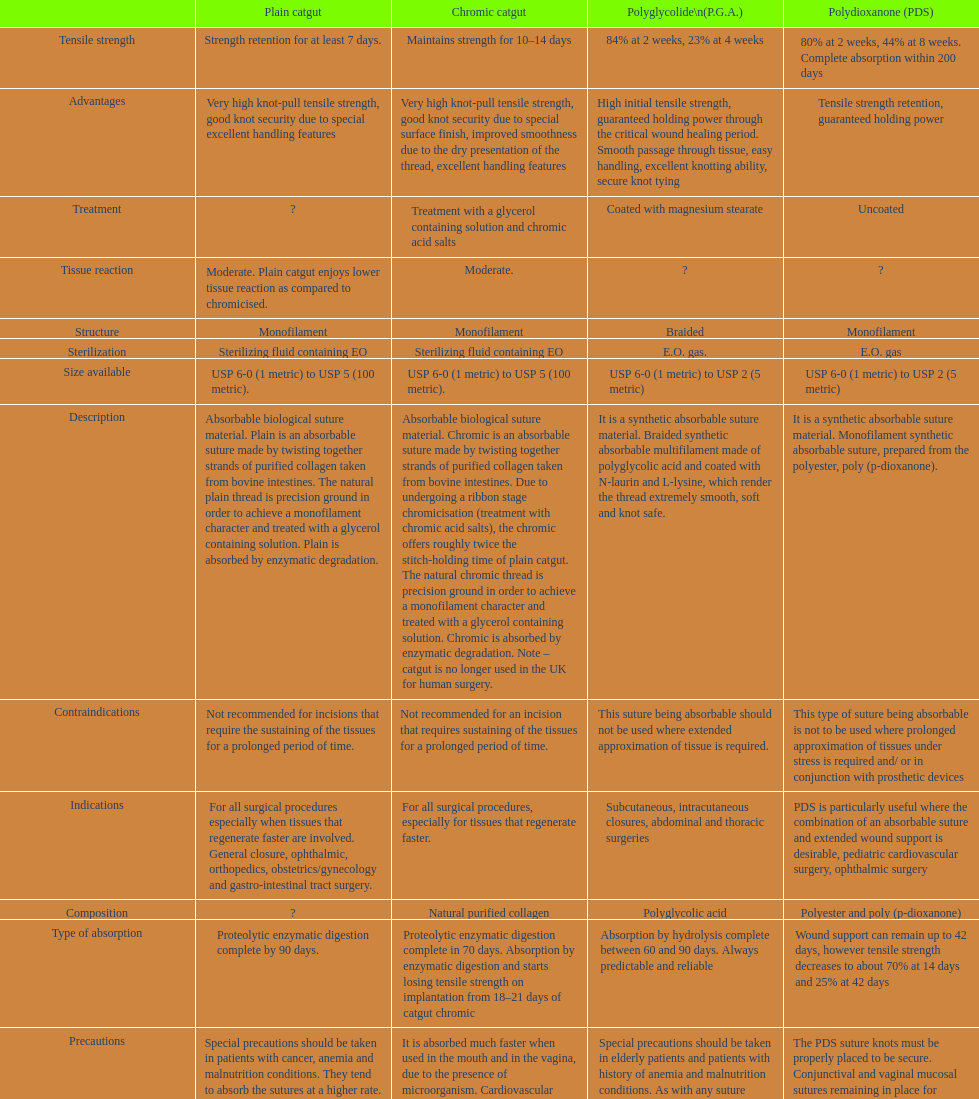Would you mind parsing the complete table? {'header': ['', 'Plain catgut', 'Chromic catgut', 'Polyglycolide\\n(P.G.A.)', 'Polydioxanone (PDS)'], 'rows': [['Tensile strength', 'Strength retention for at least 7 days.', 'Maintains strength for 10–14 days', '84% at 2 weeks, 23% at 4 weeks', '80% at 2 weeks, 44% at 8 weeks. Complete absorption within 200 days'], ['Advantages', 'Very high knot-pull tensile strength, good knot security due to special excellent handling features', 'Very high knot-pull tensile strength, good knot security due to special surface finish, improved smoothness due to the dry presentation of the thread, excellent handling features', 'High initial tensile strength, guaranteed holding power through the critical wound healing period. Smooth passage through tissue, easy handling, excellent knotting ability, secure knot tying', 'Tensile strength retention, guaranteed holding power'], ['Treatment', '?', 'Treatment with a glycerol containing solution and chromic acid salts', 'Coated with magnesium stearate', 'Uncoated'], ['Tissue reaction', 'Moderate. Plain catgut enjoys lower tissue reaction as compared to chromicised.', 'Moderate.', '?', '?'], ['Structure', 'Monofilament', 'Monofilament', 'Braided', 'Monofilament'], ['Sterilization', 'Sterilizing fluid containing EO', 'Sterilizing fluid containing EO', 'E.O. gas.', 'E.O. gas'], ['Size available', 'USP 6-0 (1 metric) to USP 5 (100 metric).', 'USP 6-0 (1 metric) to USP 5 (100 metric).', 'USP 6-0 (1 metric) to USP 2 (5 metric)', 'USP 6-0 (1 metric) to USP 2 (5 metric)'], ['Description', 'Absorbable biological suture material. Plain is an absorbable suture made by twisting together strands of purified collagen taken from bovine intestines. The natural plain thread is precision ground in order to achieve a monofilament character and treated with a glycerol containing solution. Plain is absorbed by enzymatic degradation.', 'Absorbable biological suture material. Chromic is an absorbable suture made by twisting together strands of purified collagen taken from bovine intestines. Due to undergoing a ribbon stage chromicisation (treatment with chromic acid salts), the chromic offers roughly twice the stitch-holding time of plain catgut. The natural chromic thread is precision ground in order to achieve a monofilament character and treated with a glycerol containing solution. Chromic is absorbed by enzymatic degradation. Note – catgut is no longer used in the UK for human surgery.', 'It is a synthetic absorbable suture material. Braided synthetic absorbable multifilament made of polyglycolic acid and coated with N-laurin and L-lysine, which render the thread extremely smooth, soft and knot safe.', 'It is a synthetic absorbable suture material. Monofilament synthetic absorbable suture, prepared from the polyester, poly (p-dioxanone).'], ['Contraindications', 'Not recommended for incisions that require the sustaining of the tissues for a prolonged period of time.', 'Not recommended for an incision that requires sustaining of the tissues for a prolonged period of time.', 'This suture being absorbable should not be used where extended approximation of tissue is required.', 'This type of suture being absorbable is not to be used where prolonged approximation of tissues under stress is required and/ or in conjunction with prosthetic devices'], ['Indications', 'For all surgical procedures especially when tissues that regenerate faster are involved. General closure, ophthalmic, orthopedics, obstetrics/gynecology and gastro-intestinal tract surgery.', 'For all surgical procedures, especially for tissues that regenerate faster.', 'Subcutaneous, intracutaneous closures, abdominal and thoracic surgeries', 'PDS is particularly useful where the combination of an absorbable suture and extended wound support is desirable, pediatric cardiovascular surgery, ophthalmic surgery'], ['Composition', '?', 'Natural purified collagen', 'Polyglycolic acid', 'Polyester and poly (p-dioxanone)'], ['Type of absorption', 'Proteolytic enzymatic digestion complete by 90 days.', 'Proteolytic enzymatic digestion complete in 70 days. Absorption by enzymatic digestion and starts losing tensile strength on implantation from 18–21 days of catgut chromic', 'Absorption by hydrolysis complete between 60 and 90 days. Always predictable and reliable', 'Wound support can remain up to 42 days, however tensile strength decreases to about 70% at 14 days and 25% at 42 days'], ['Precautions', 'Special precautions should be taken in patients with cancer, anemia and malnutrition conditions. They tend to absorb the sutures at a higher rate. Cardiovascular surgery, due to the continued heart contractions. It is absorbed much faster when used in the mouth and in the vagina, due to the presence of microorganisms. Avoid using where long term tissue approximation is needed. Absorption is faster in infected tissues', 'It is absorbed much faster when used in the mouth and in the vagina, due to the presence of microorganism. Cardiovascular surgery, due to the continued heart contractions. Special precautions should be taken in patients with cancer, anemia and malnutrition conditions. They tend to absorb this suture at a higher rate.', 'Special precautions should be taken in elderly patients and patients with history of anemia and malnutrition conditions. As with any suture material, adequate knot security requires the accepted surgical technique of flat and square ties.', 'The PDS suture knots must be properly placed to be secure. Conjunctival and vaginal mucosal sutures remaining in place for extended periods may be associated with localized irritation. Subcuticular sutures should be placed as deeply as possible in order to minimize the erythema and induration normally associated with absorption.'], ['Thread color', 'Straw', 'Brown', 'Violet and undyed', 'Violet and clear'], ['Origin', 'Bovine serosa surface finish.', 'Bovine serosa', 'Synthetic', 'Synthetic through the critical wound']]} What type of suture is not to be used in conjunction with prosthetic devices? Polydioxanone (PDS). 